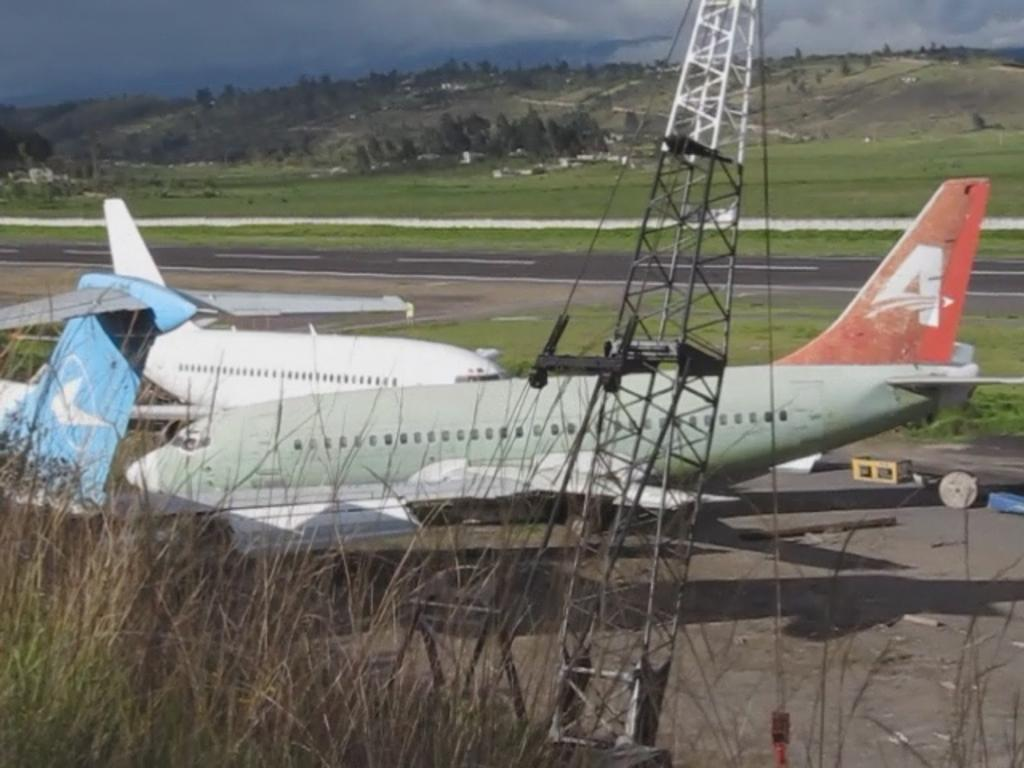<image>
Provide a brief description of the given image. a plane with the letter 'a' on the side of it 